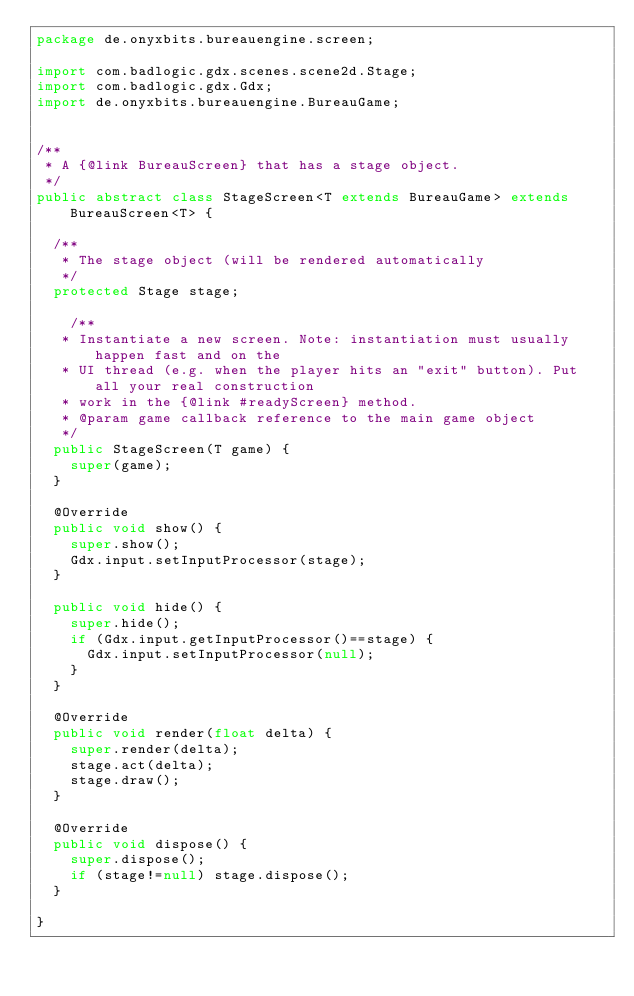<code> <loc_0><loc_0><loc_500><loc_500><_Java_>package de.onyxbits.bureauengine.screen;

import com.badlogic.gdx.scenes.scene2d.Stage;
import com.badlogic.gdx.Gdx;
import de.onyxbits.bureauengine.BureauGame;


/**
 * A {@link BureauScreen} that has a stage object.
 */
public abstract class StageScreen<T extends BureauGame> extends BureauScreen<T> {

  /**
   * The stage object (will be rendered automatically
   */
  protected Stage stage;
  
    /**
   * Instantiate a new screen. Note: instantiation must usually happen fast and on the
   * UI thread (e.g. when the player hits an "exit" button). Put all your real construction
   * work in the {@link #readyScreen} method.
   * @param game callback reference to the main game object
   */
  public StageScreen(T game) {
    super(game);
  }
  
  @Override
  public void show() {
    super.show();
    Gdx.input.setInputProcessor(stage);
  }
  
  public void hide() {
    super.hide();
    if (Gdx.input.getInputProcessor()==stage) {
      Gdx.input.setInputProcessor(null);
    }
  }
  
  @Override
  public void render(float delta) {
    super.render(delta);
    stage.act(delta);
    stage.draw();
  }
  
  @Override
  public void dispose() {
    super.dispose();
    if (stage!=null) stage.dispose();
  }
     
}
</code> 